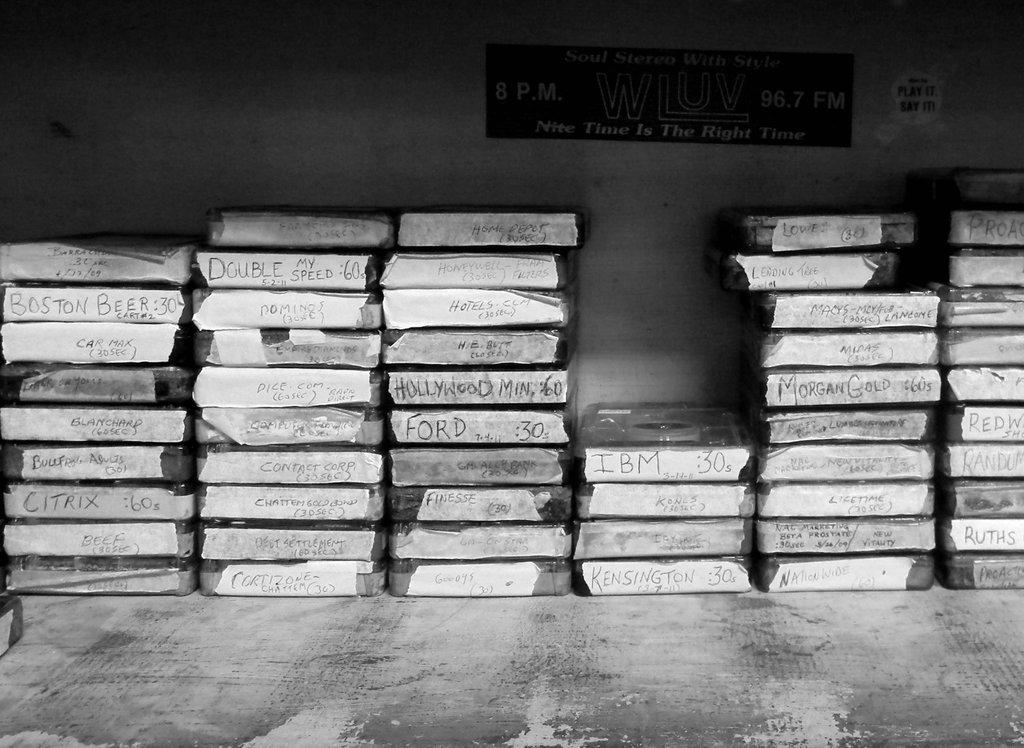<image>
Present a compact description of the photo's key features. a black and white picture of old tapes titled IBM and Boston Beer 